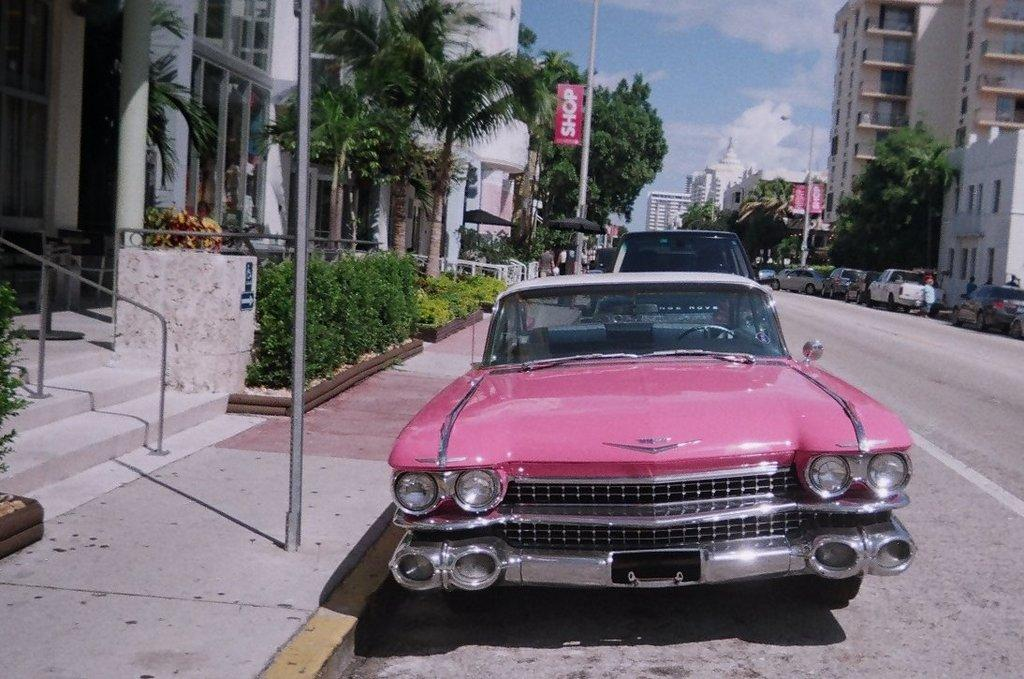What type of vehicles can be seen on the road in the image? There are cars on the road in the image. What structures are visible in the image besides the cars? There are poles, trees, and buildings visible in the image. What is visible at the top of the image? The sky is visible at the top of the image. Where is the lumber being transported in the image? There is no lumber present in the image. Can you see a trail leading into the woods in the image? There is no trail visible in the image. 